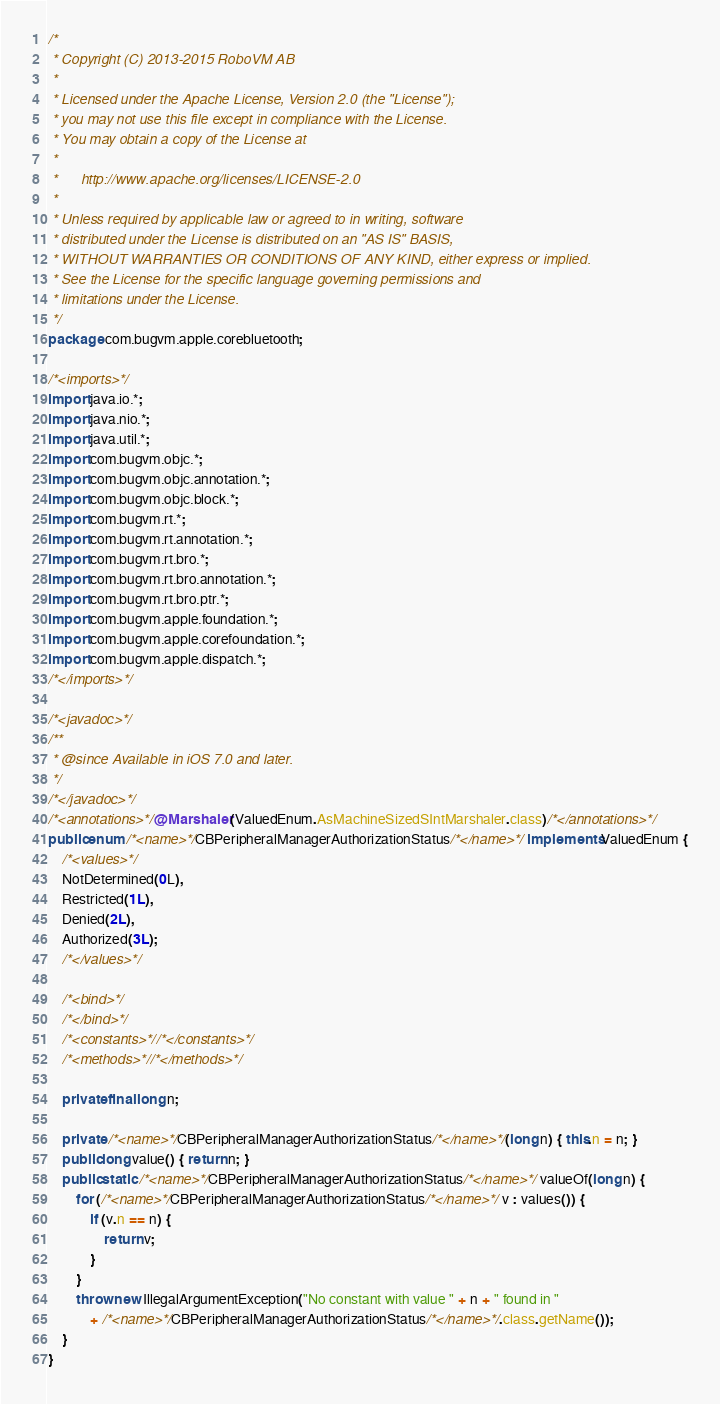Convert code to text. <code><loc_0><loc_0><loc_500><loc_500><_Java_>/*
 * Copyright (C) 2013-2015 RoboVM AB
 *
 * Licensed under the Apache License, Version 2.0 (the "License");
 * you may not use this file except in compliance with the License.
 * You may obtain a copy of the License at
 *
 *      http://www.apache.org/licenses/LICENSE-2.0
 *
 * Unless required by applicable law or agreed to in writing, software
 * distributed under the License is distributed on an "AS IS" BASIS,
 * WITHOUT WARRANTIES OR CONDITIONS OF ANY KIND, either express or implied.
 * See the License for the specific language governing permissions and
 * limitations under the License.
 */
package com.bugvm.apple.corebluetooth;

/*<imports>*/
import java.io.*;
import java.nio.*;
import java.util.*;
import com.bugvm.objc.*;
import com.bugvm.objc.annotation.*;
import com.bugvm.objc.block.*;
import com.bugvm.rt.*;
import com.bugvm.rt.annotation.*;
import com.bugvm.rt.bro.*;
import com.bugvm.rt.bro.annotation.*;
import com.bugvm.rt.bro.ptr.*;
import com.bugvm.apple.foundation.*;
import com.bugvm.apple.corefoundation.*;
import com.bugvm.apple.dispatch.*;
/*</imports>*/

/*<javadoc>*/
/**
 * @since Available in iOS 7.0 and later.
 */
/*</javadoc>*/
/*<annotations>*/@Marshaler(ValuedEnum.AsMachineSizedSIntMarshaler.class)/*</annotations>*/
public enum /*<name>*/CBPeripheralManagerAuthorizationStatus/*</name>*/ implements ValuedEnum {
    /*<values>*/
    NotDetermined(0L),
    Restricted(1L),
    Denied(2L),
    Authorized(3L);
    /*</values>*/

    /*<bind>*/
    /*</bind>*/
    /*<constants>*//*</constants>*/
    /*<methods>*//*</methods>*/

    private final long n;

    private /*<name>*/CBPeripheralManagerAuthorizationStatus/*</name>*/(long n) { this.n = n; }
    public long value() { return n; }
    public static /*<name>*/CBPeripheralManagerAuthorizationStatus/*</name>*/ valueOf(long n) {
        for (/*<name>*/CBPeripheralManagerAuthorizationStatus/*</name>*/ v : values()) {
            if (v.n == n) {
                return v;
            }
        }
        throw new IllegalArgumentException("No constant with value " + n + " found in " 
            + /*<name>*/CBPeripheralManagerAuthorizationStatus/*</name>*/.class.getName());
    }
}
</code> 